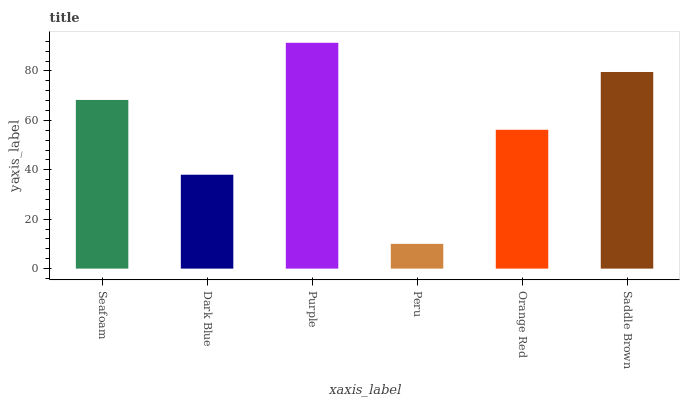Is Dark Blue the minimum?
Answer yes or no. No. Is Dark Blue the maximum?
Answer yes or no. No. Is Seafoam greater than Dark Blue?
Answer yes or no. Yes. Is Dark Blue less than Seafoam?
Answer yes or no. Yes. Is Dark Blue greater than Seafoam?
Answer yes or no. No. Is Seafoam less than Dark Blue?
Answer yes or no. No. Is Seafoam the high median?
Answer yes or no. Yes. Is Orange Red the low median?
Answer yes or no. Yes. Is Purple the high median?
Answer yes or no. No. Is Saddle Brown the low median?
Answer yes or no. No. 